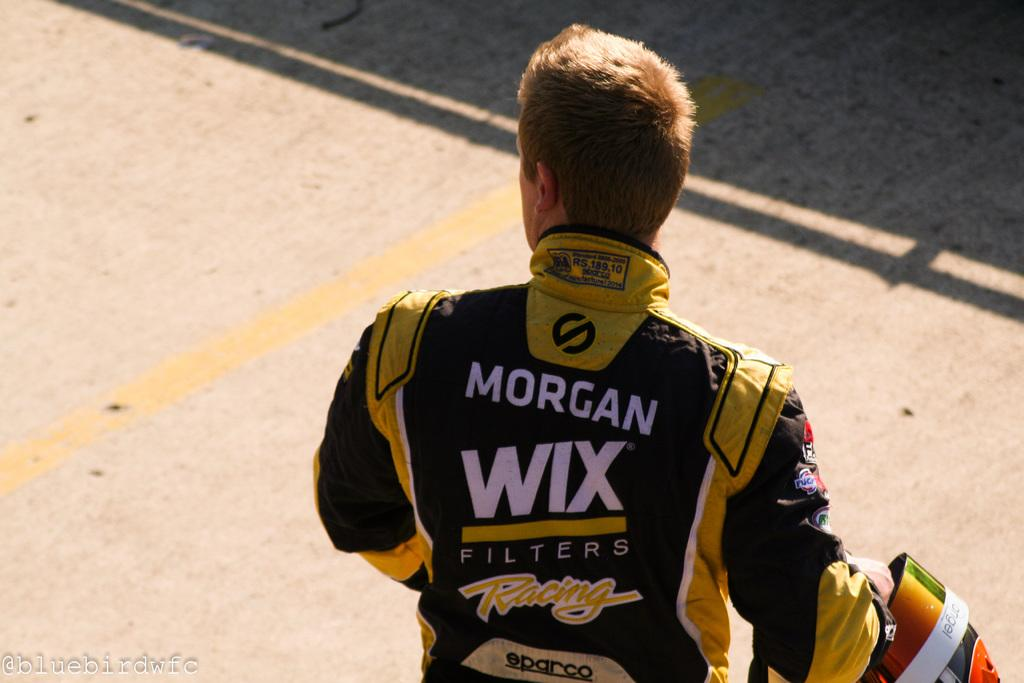<image>
Relay a brief, clear account of the picture shown. A racing driver wearing a uniform sponsored by Wix Filters 